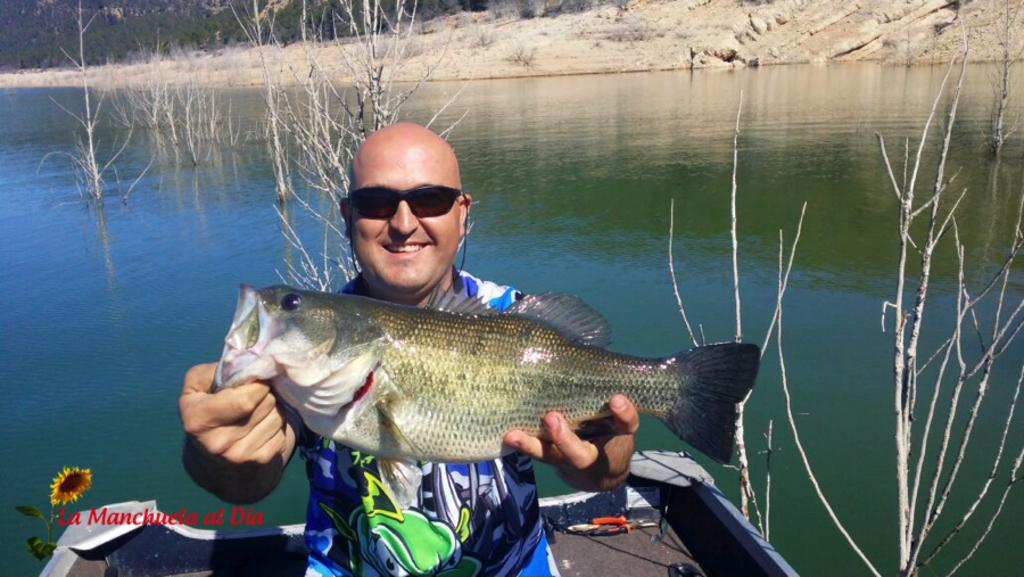Who is present in the image? There is a man in the picture. What is the man holding in the image? The man is holding a fish. Can you describe the man's appearance? The man is wearing spectacles. What can be seen in the background of the image? There is water visible in the background of the picture. What type of ice can be seen melting on the van in the image? There is no ice or van present in the image; it features a man holding a fish and wearing spectacles with water visible in the background. 